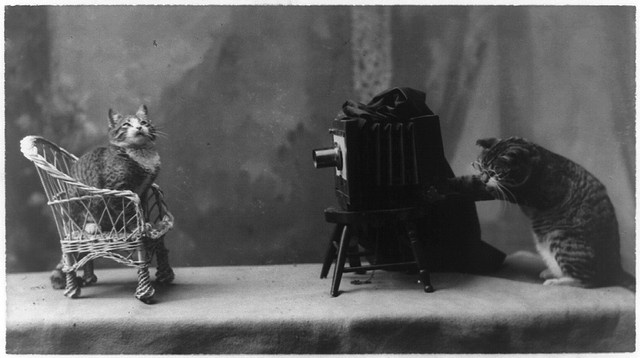Describe the objects in this image and their specific colors. I can see cat in black, gray, darkgray, and white tones, chair in white, gray, black, darkgray, and lightgray tones, and cat in white, gray, black, darkgray, and lightgray tones in this image. 